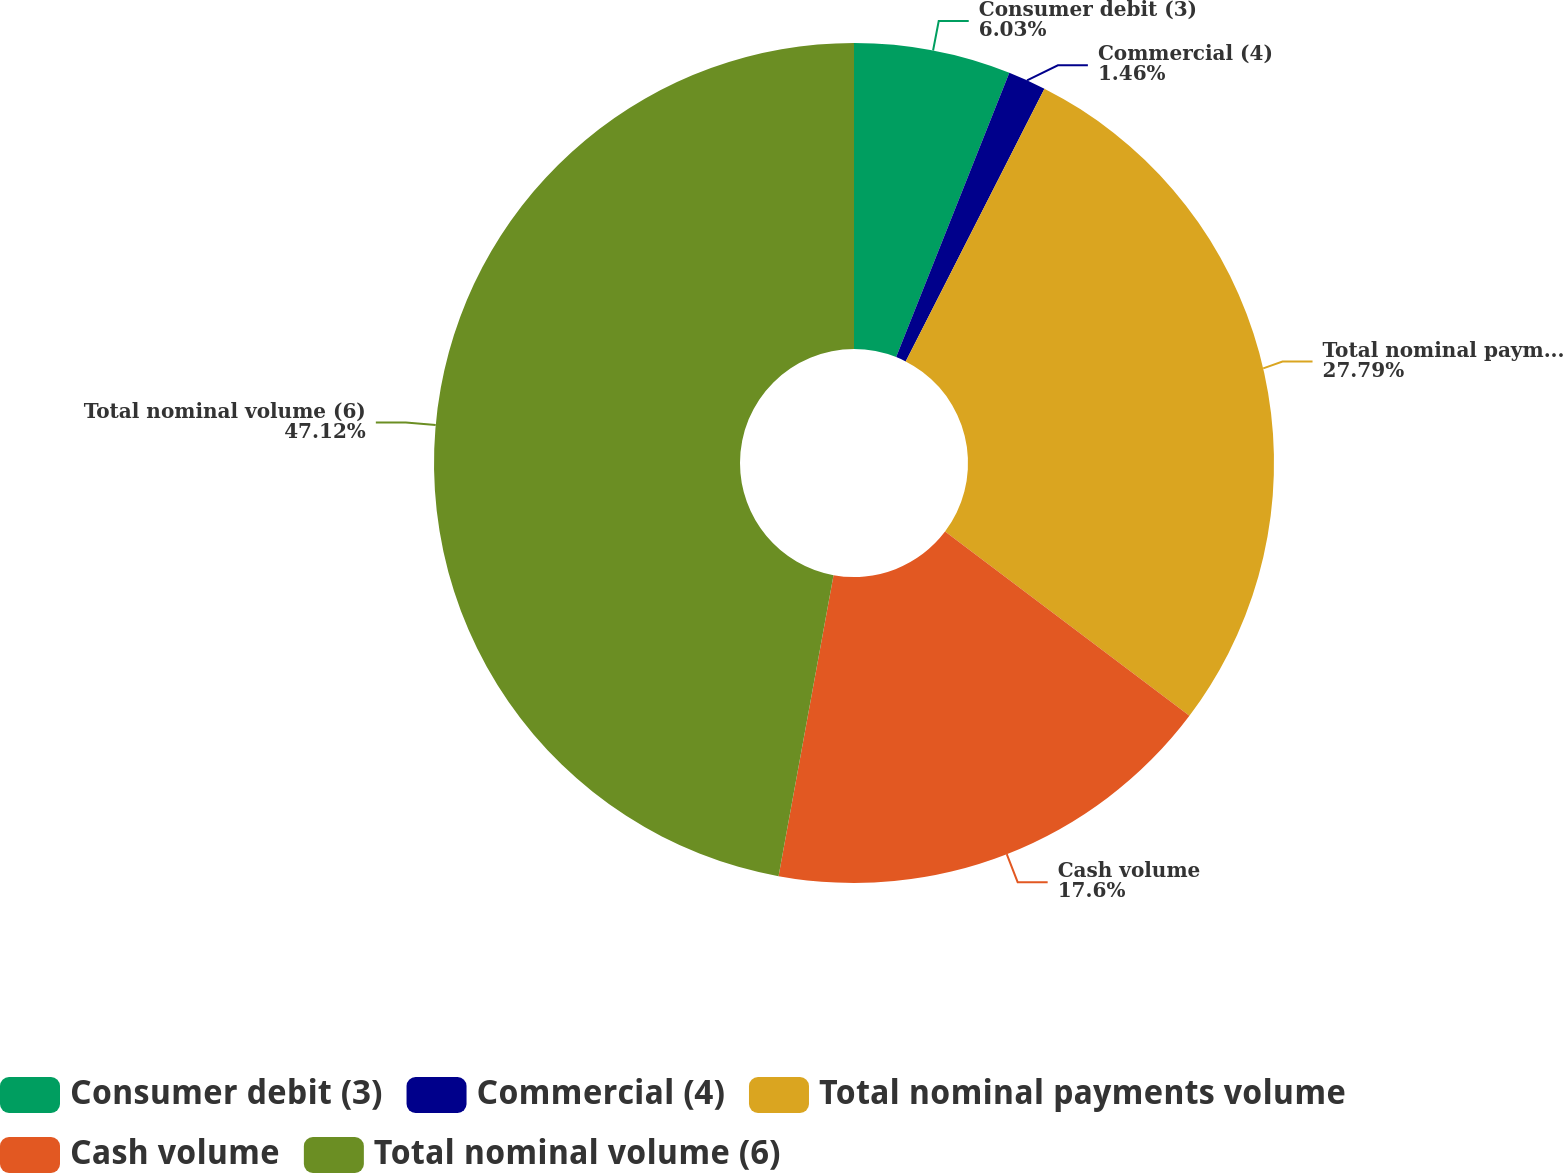Convert chart. <chart><loc_0><loc_0><loc_500><loc_500><pie_chart><fcel>Consumer debit (3)<fcel>Commercial (4)<fcel>Total nominal payments volume<fcel>Cash volume<fcel>Total nominal volume (6)<nl><fcel>6.03%<fcel>1.46%<fcel>27.79%<fcel>17.6%<fcel>47.13%<nl></chart> 